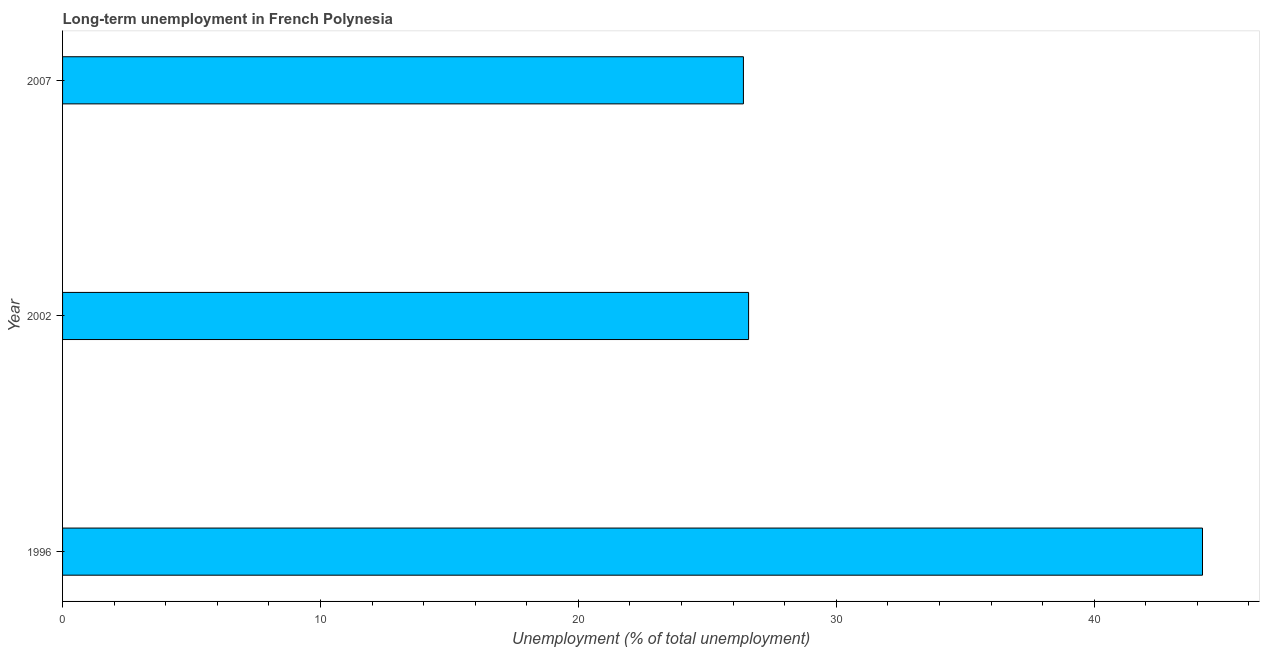What is the title of the graph?
Make the answer very short. Long-term unemployment in French Polynesia. What is the label or title of the X-axis?
Provide a succinct answer. Unemployment (% of total unemployment). What is the label or title of the Y-axis?
Your answer should be very brief. Year. What is the long-term unemployment in 1996?
Keep it short and to the point. 44.2. Across all years, what is the maximum long-term unemployment?
Give a very brief answer. 44.2. Across all years, what is the minimum long-term unemployment?
Give a very brief answer. 26.4. In which year was the long-term unemployment minimum?
Keep it short and to the point. 2007. What is the sum of the long-term unemployment?
Give a very brief answer. 97.2. What is the average long-term unemployment per year?
Your answer should be compact. 32.4. What is the median long-term unemployment?
Keep it short and to the point. 26.6. In how many years, is the long-term unemployment greater than 26 %?
Give a very brief answer. 3. What is the ratio of the long-term unemployment in 1996 to that in 2002?
Offer a terse response. 1.66. Is the long-term unemployment in 2002 less than that in 2007?
Offer a very short reply. No. Is the difference between the long-term unemployment in 2002 and 2007 greater than the difference between any two years?
Offer a terse response. No. Is the sum of the long-term unemployment in 2002 and 2007 greater than the maximum long-term unemployment across all years?
Your answer should be very brief. Yes. What is the difference between the highest and the lowest long-term unemployment?
Offer a terse response. 17.8. Are all the bars in the graph horizontal?
Your response must be concise. Yes. Are the values on the major ticks of X-axis written in scientific E-notation?
Your response must be concise. No. What is the Unemployment (% of total unemployment) of 1996?
Offer a terse response. 44.2. What is the Unemployment (% of total unemployment) in 2002?
Offer a terse response. 26.6. What is the Unemployment (% of total unemployment) of 2007?
Provide a succinct answer. 26.4. What is the difference between the Unemployment (% of total unemployment) in 2002 and 2007?
Provide a short and direct response. 0.2. What is the ratio of the Unemployment (% of total unemployment) in 1996 to that in 2002?
Offer a very short reply. 1.66. What is the ratio of the Unemployment (% of total unemployment) in 1996 to that in 2007?
Provide a succinct answer. 1.67. What is the ratio of the Unemployment (% of total unemployment) in 2002 to that in 2007?
Ensure brevity in your answer.  1.01. 